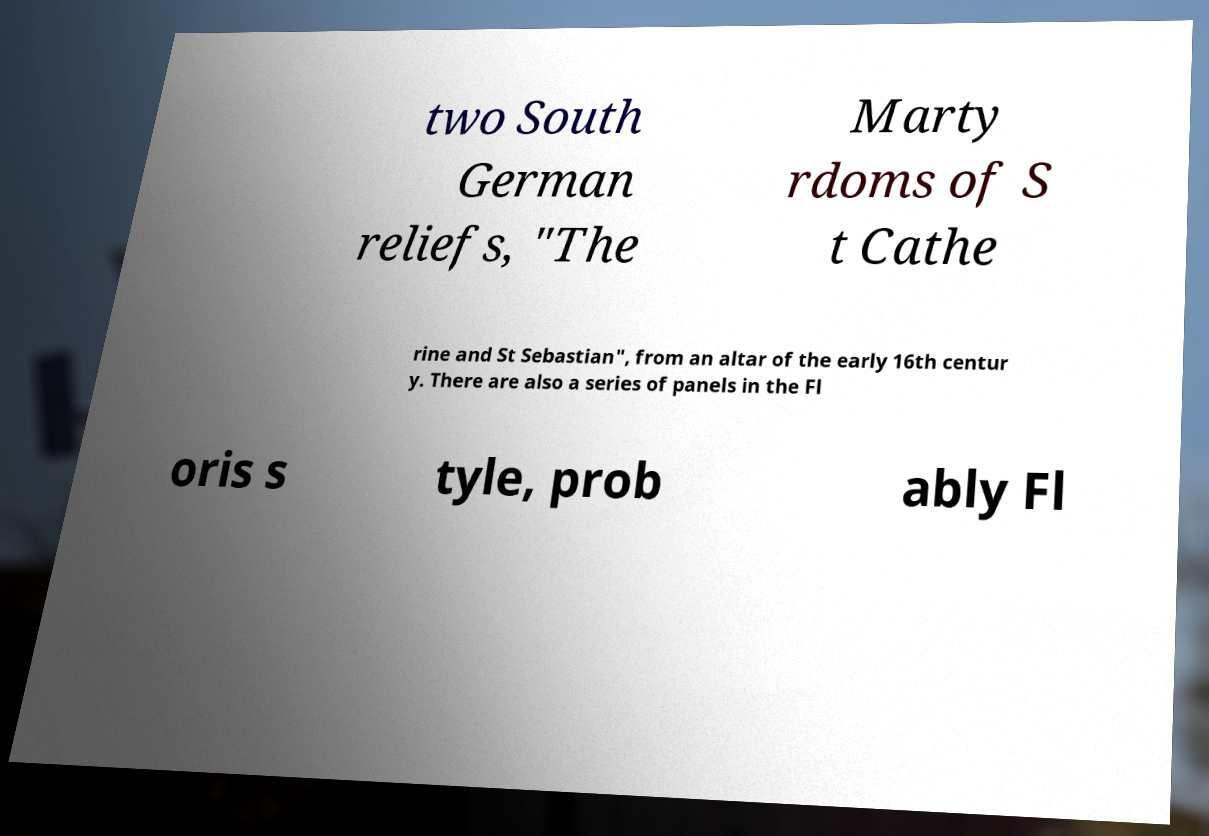Can you read and provide the text displayed in the image?This photo seems to have some interesting text. Can you extract and type it out for me? two South German reliefs, "The Marty rdoms of S t Cathe rine and St Sebastian", from an altar of the early 16th centur y. There are also a series of panels in the Fl oris s tyle, prob ably Fl 